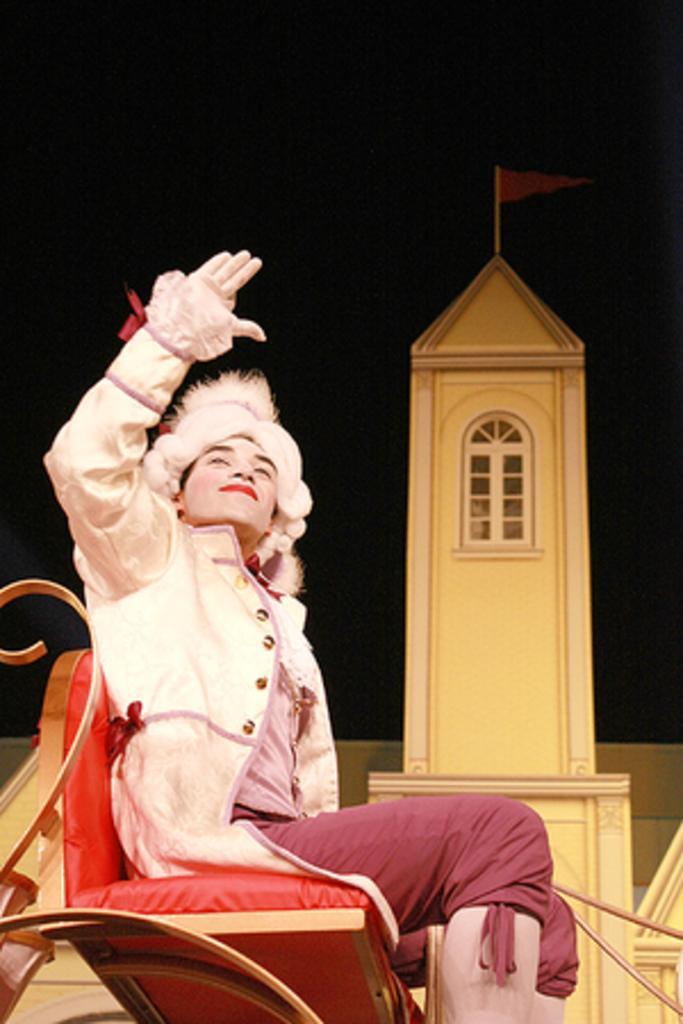In one or two sentences, can you explain what this image depicts? In this image there is a person sitting on the chair. At the back side there is a tower and on top of it there is a flag. 